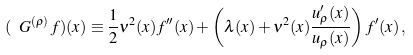<formula> <loc_0><loc_0><loc_500><loc_500>( \ G ^ { ( \rho ) } \, f ) ( x ) \equiv \frac { 1 } { 2 } \nu ^ { 2 } ( x ) f ^ { \prime \prime } ( x ) + \left ( \lambda ( x ) + \nu ^ { 2 } ( x ) \frac { u ^ { \prime } _ { \rho } ( x ) } { u _ { \rho } ( x ) } \right ) f ^ { \prime } ( x ) \, ,</formula> 